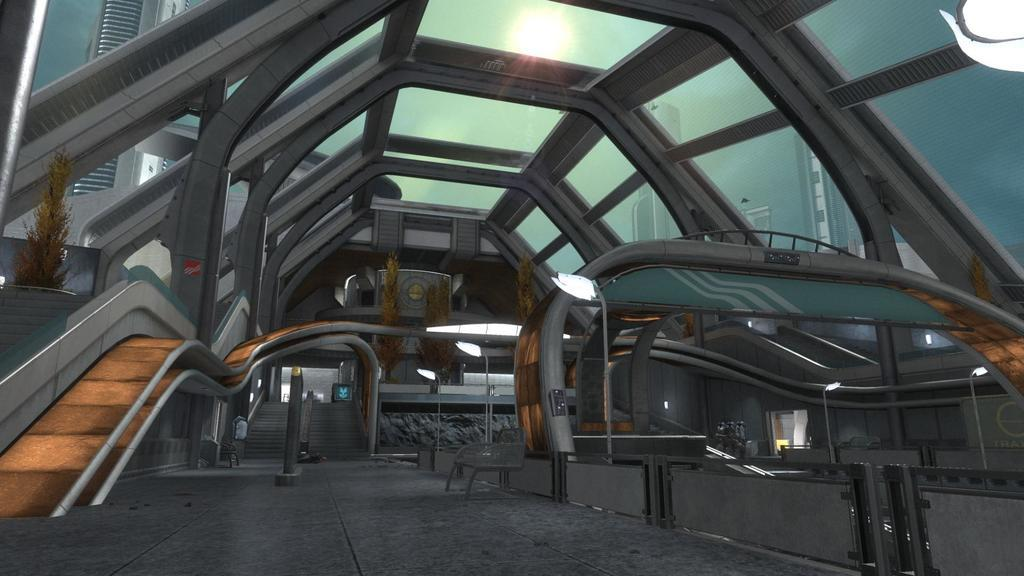What type of location is depicted in the image? The image shows an inside view of a building. What can be seen hanging from the ceiling in the building? There are poles with lights in the building. What type of furniture is present in the building? There are benches in the building. How can one move between different levels in the building? There are stairs in the building. Is there any greenery inside the building? Yes, there is a plant in the building. What can be seen outside the building through the glass? Other buildings are partially visible through the glass. What type of cup is being used to express anger in the image? There is no cup or expression of anger present in the image. Can you see any ducks swimming in the building? There are no ducks present in the image; it shows an indoor space with various objects and features. 